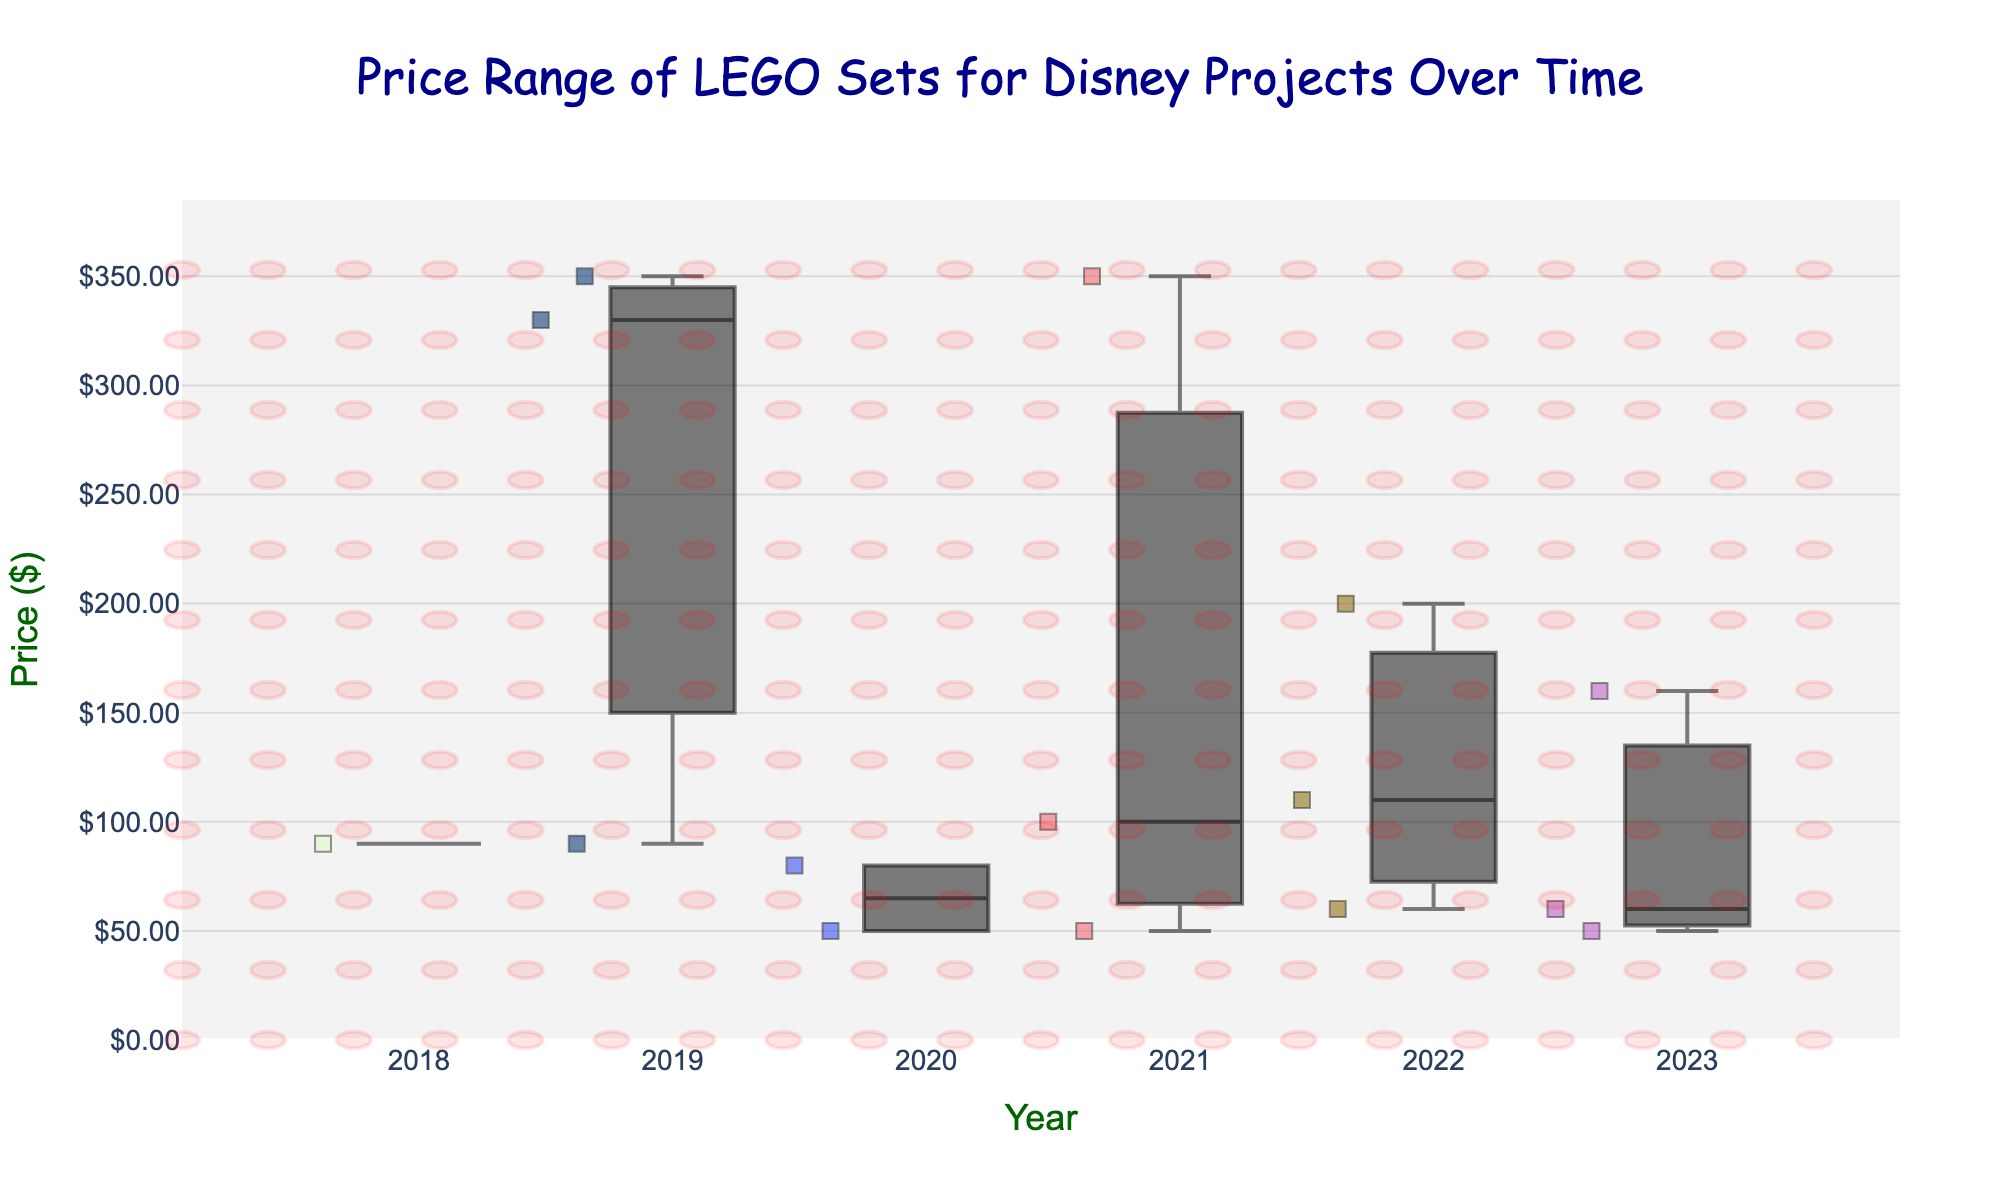What is the title of the figure? The title is usually found at the top of the figure and indicates what the plot is about. In this case, it is mentioned in the code as well.
Answer: Price Range of LEGO Sets for Disney Projects Over Time What is the y-axis labeled as? The y-axis label is located along the vertical axis and describes the variable being measured. Here, it is specified in the code block.
Answer: Price ($) Which year has the highest median price for the LEGO sets? To find the year with the highest median, look at the boxes in the box plot and identify the one which has the middle line (median) at the highest position.
Answer: 2019 What is the price range for the LEGO sets in 2019? The price range is determined by looking at the minimum and maximum prices represented by the bottom and top whiskers in the box plot for that year.
Answer: $89.99 to $349.99 How many outlier points are there in the year 2022? Outlier points are usually indicated by points outside the whiskers. Count the number of such points visible for the year 2022.
Answer: 0 Which year has the lowest priced LEGO set and what is its price? Determine the year by looking at the lowest points across all box plots and then check the value next to this point.
Answer: 2023, $49.99 Is the median price of LEGO sets for 2020 higher or lower than that for 2021? Compare the median line's positions in the boxes for 2020 and 2021 to see which is higher or lower.
Answer: Lower Did the price range of LEGO sets increase or decrease from 2021 to 2022? Compare the height of the boxes and whiskers for these years to determine the change in price range.
Answer: Decrease What is the interquartile range (IQR) for the LEGO sets in 2018? The IQR is the range between the first quartile (bottom of the box) and the third quartile (top of the box). Measure this distance on the box plot for 2018.
Answer: $89.99 to $89.99 (0, since there's only one point) Which year shows the most variation in LEGO set prices? Variation can be assessed by looking at the year with the tallest box and whiskers, representing the widest range.
Answer: 2019 